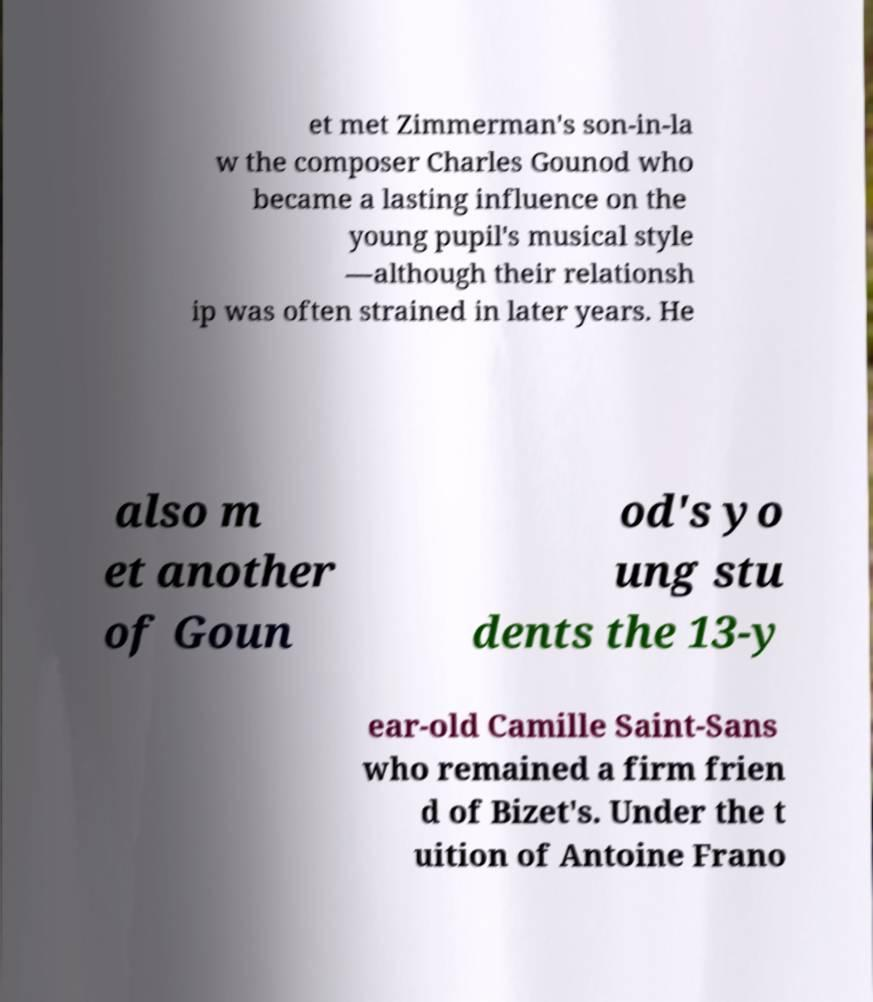Can you accurately transcribe the text from the provided image for me? et met Zimmerman's son-in-la w the composer Charles Gounod who became a lasting influence on the young pupil's musical style —although their relationsh ip was often strained in later years. He also m et another of Goun od's yo ung stu dents the 13-y ear-old Camille Saint-Sans who remained a firm frien d of Bizet's. Under the t uition of Antoine Frano 